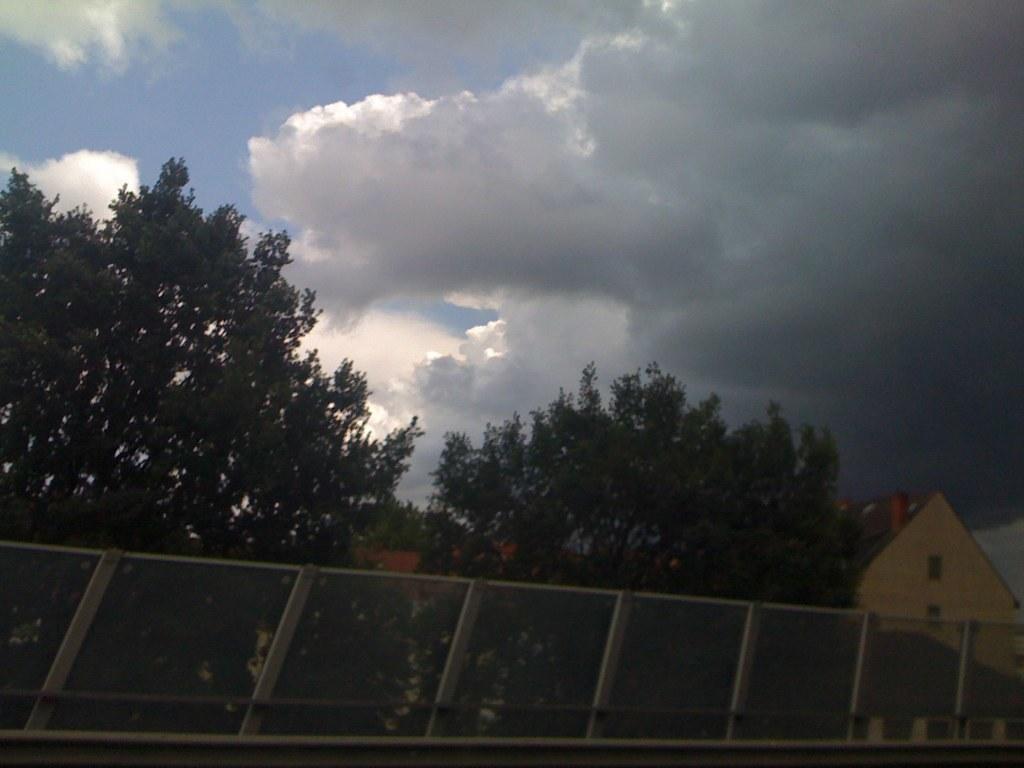Describe this image in one or two sentences. In this image at the bottom there are some houses and net and some trees on the top of the image there is sky. 